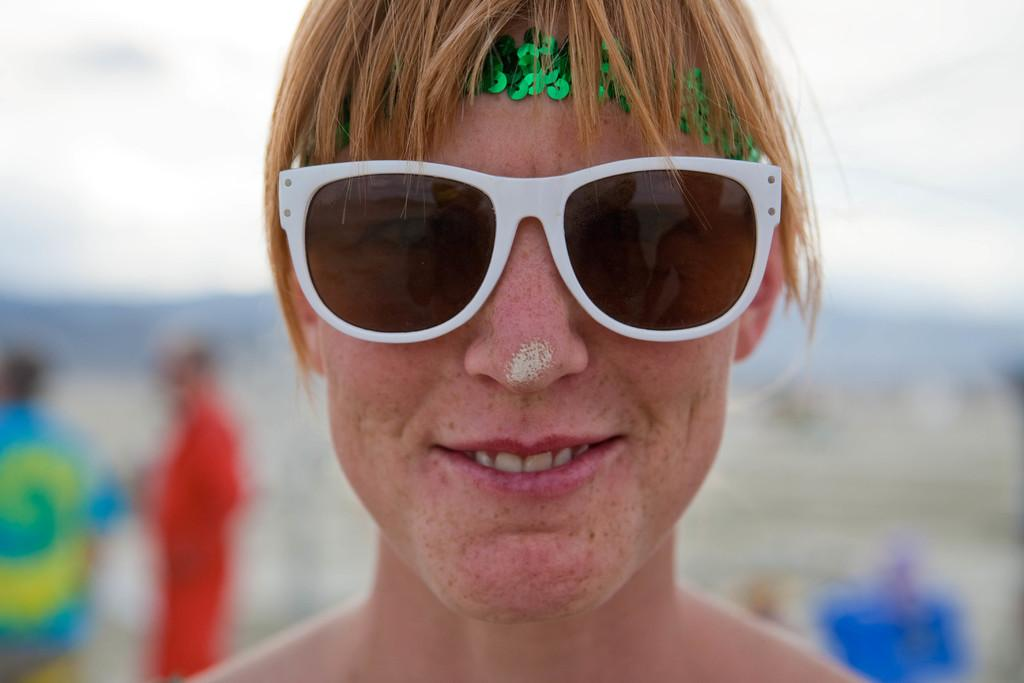What can be seen in the image? There is a person in the image. What is the person wearing on their head? The person is wearing a green band. What type of eyewear is the person wearing? The person is wearing white goggles. Can you describe the background of the image? The background of the image is blurred. What type of polish is the person applying to their nails in the image? There is no indication in the image that the person is applying polish to their nails, nor is there any polish visible. 